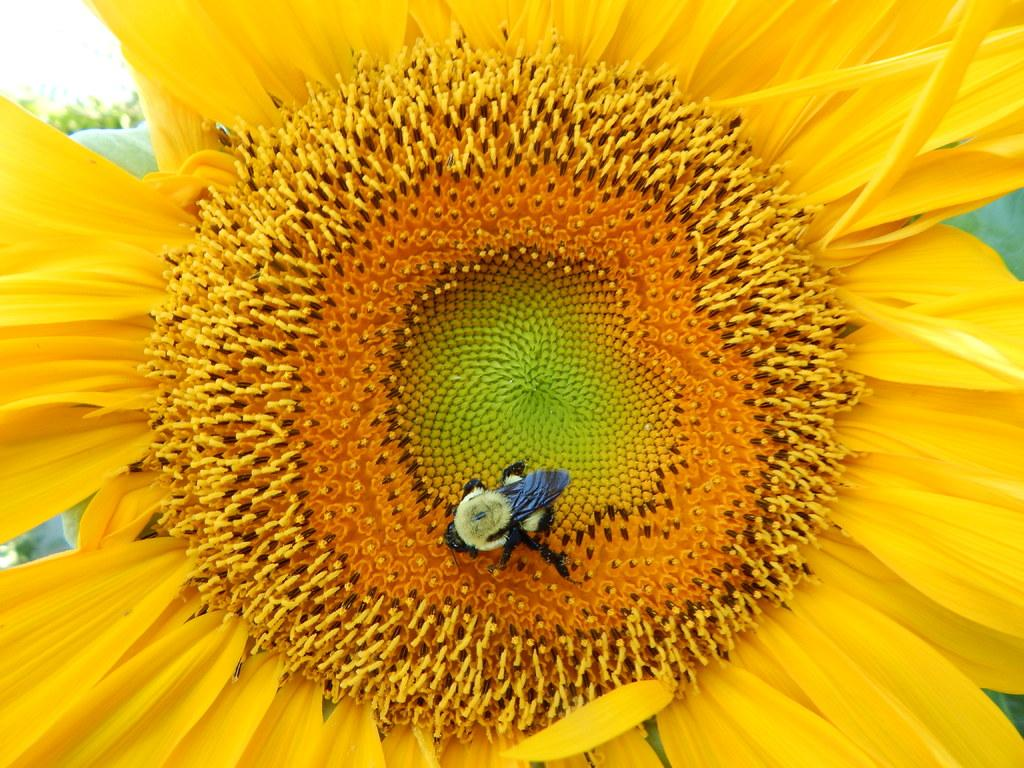What is present in the picture? There is a flower in the picture. Can you describe the flower's appearance? The flower is yellow in color. Is there anything else present on the flower? Yes, there is an insect on the flower. Where is the camera located in the image? There is no camera present in the image; it features a flower with a yellow color and an insect on it. How many quarters can be seen on the flower? There are no quarters present on the flower; it only has an insect on it. 